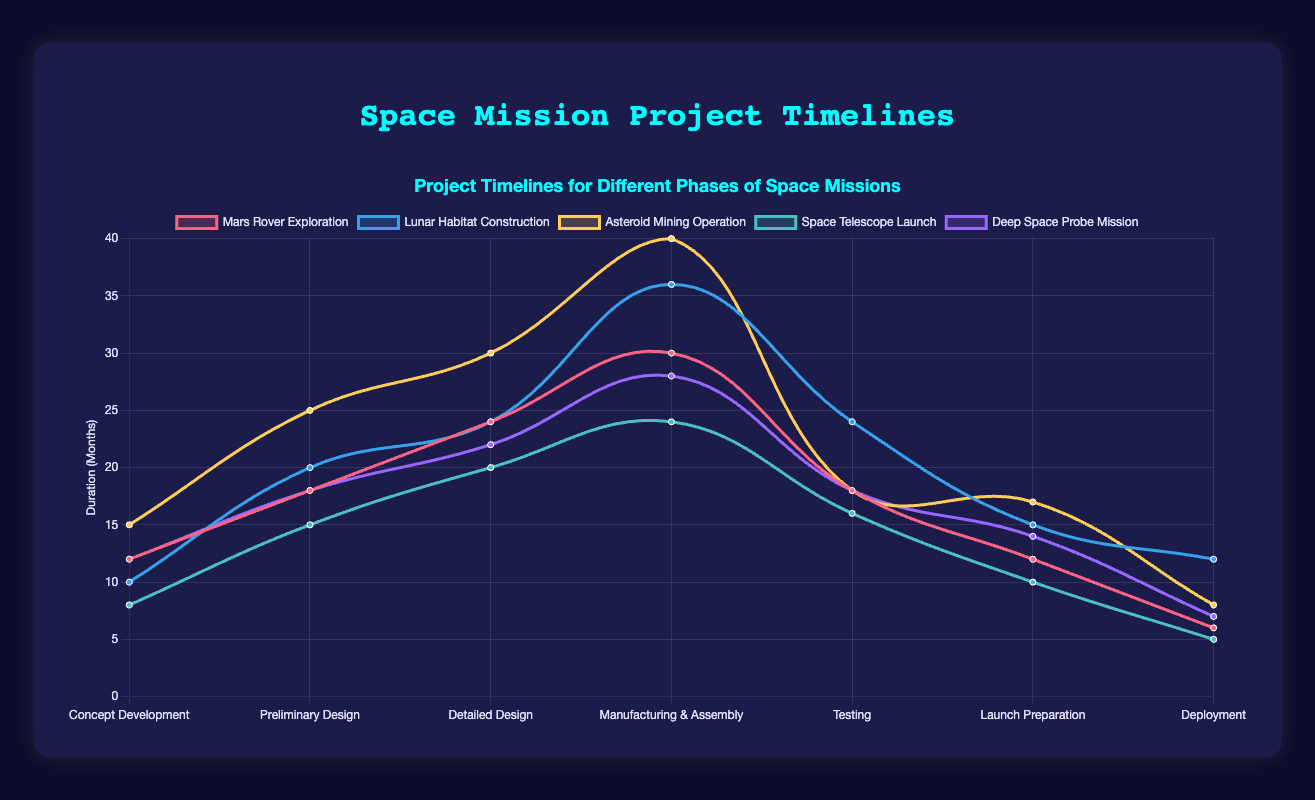Which mission has the longest duration for the Detailed Design phase? By looking at the Detailed Design phase across all missions, the Asteroid Mining Operation shows the longest duration of 30 months.
Answer: Asteroid Mining Operation Which mission involves the shortest duration for the Testing phase? Checking the Testing phase durations, we see the Space Telescope Launch has the shortest duration at 16 months.
Answer: Space Telescope Launch What is the average duration of the Manufacturing & Assembly phase across all missions? To find the average, sum up the durations of the Manufacturing & Assembly phase for all five missions: (30 + 36 + 40 + 24 + 28) = 158. Then divide by the number of missions: 158 / 5 = 31.6 months.
Answer: 31.6 months Which mission requires more time for Launch Preparation, the Lunar Habitat Construction or the Asteroid Mining Operation? Comparing the Launch Preparation durations, Lunar Habitat Construction has 15 months and Asteroid Mining Operation has 17 months. Hence, the Asteroid Mining Operation requires more time.
Answer: Asteroid Mining Operation Which mission has the highest total project duration across all phases? By summing up the durations of all phases, the highest total project duration is:
Mars Rover Exploration: 120 months,
Lunar Habitat Construction: 141 months,
Asteroid Mining Operation: 153 months,
Space Telescope Launch: 98 months,
Deep Space Probe Mission: 119 months.
The Asteroid Mining Operation has the highest total duration.
Answer: Asteroid Mining Operation Which phase has the most variation in duration across all missions? By comparing the standard deviation of phase durations across missions, we can see significant variations:
Concept Development: 7.45,
Preliminary Design: 4.58,
Detailed Design: 3.87,
Manufacturing & Assembly: 5.96,
Testing: 3.42,
Launch Preparation: 3.12,
Deployment: 2.6.
The Concept Development phase has the highest variation with a standard deviation of 7.45.
Answer: Concept Development In the final Deployment phase, which mission has the second shortest duration? Looking at the Deployment phase durations: Mars Rover Exploration (6), Lunar Habitat Construction (12), Asteroid Mining Operation (8), Space Telescope Launch (5), and Deep Space Probe Mission (7), the second shortest duration after Space Telescope Launch (5) is Mars Rover Exploration (6).
Answer: Mars Rover Exploration Which mission's phases show a steady increase in duration from Concept Development to Deployment? A steady increase in durations for each subsequent phase is observed in the Mars Rover Exploration: (12, 18, 24, 30, 18, 12, 6).
Answer: Mars Rover Exploration 